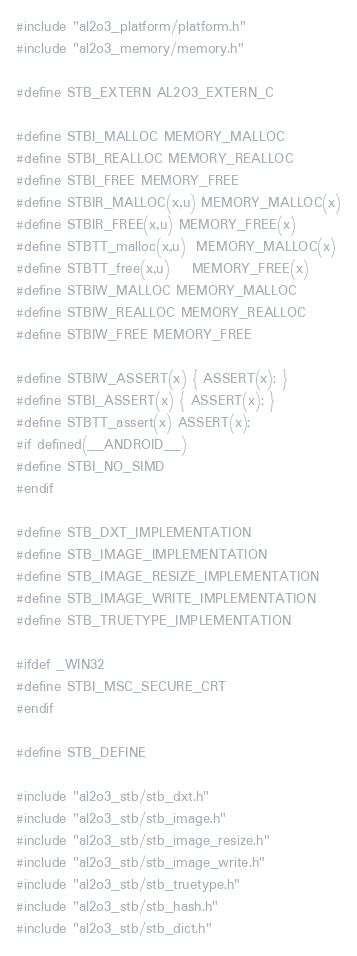<code> <loc_0><loc_0><loc_500><loc_500><_C_>#include "al2o3_platform/platform.h"
#include "al2o3_memory/memory.h"

#define STB_EXTERN AL2O3_EXTERN_C

#define STBI_MALLOC MEMORY_MALLOC
#define STBI_REALLOC MEMORY_REALLOC
#define STBI_FREE MEMORY_FREE
#define STBIR_MALLOC(x,u) MEMORY_MALLOC(x)
#define STBIR_FREE(x,u) MEMORY_FREE(x)
#define STBTT_malloc(x,u)  MEMORY_MALLOC(x)
#define STBTT_free(x,u)    MEMORY_FREE(x)
#define STBIW_MALLOC MEMORY_MALLOC
#define STBIW_REALLOC MEMORY_REALLOC
#define STBIW_FREE MEMORY_FREE

#define STBIW_ASSERT(x) { ASSERT(x); }
#define STBI_ASSERT(x) { ASSERT(x); }
#define STBTT_assert(x) ASSERT(x);
#if defined(__ANDROID__)
#define STBI_NO_SIMD
#endif

#define STB_DXT_IMPLEMENTATION
#define STB_IMAGE_IMPLEMENTATION
#define STB_IMAGE_RESIZE_IMPLEMENTATION
#define STB_IMAGE_WRITE_IMPLEMENTATION
#define STB_TRUETYPE_IMPLEMENTATION

#ifdef _WIN32
#define STBI_MSC_SECURE_CRT
#endif

#define STB_DEFINE

#include "al2o3_stb/stb_dxt.h"
#include "al2o3_stb/stb_image.h"
#include "al2o3_stb/stb_image_resize.h"
#include "al2o3_stb/stb_image_write.h"
#include "al2o3_stb/stb_truetype.h"
#include "al2o3_stb/stb_hash.h"
#include "al2o3_stb/stb_dict.h"</code> 